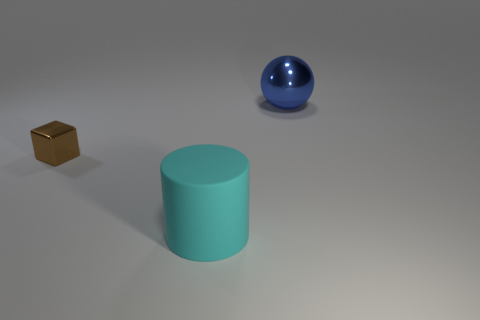Does the large blue thing have the same material as the big cylinder?
Provide a short and direct response. No. What shape is the other object that is the same size as the cyan thing?
Provide a short and direct response. Sphere. There is a thing that is left of the large thing in front of the shiny thing right of the big cyan rubber object; what is it made of?
Offer a very short reply. Metal. What number of other objects are there of the same material as the cyan cylinder?
Make the answer very short. 0. Is the object that is in front of the small brown metallic cube made of the same material as the thing that is behind the brown metallic thing?
Keep it short and to the point. No. There is a brown object that is the same material as the large blue sphere; what shape is it?
Your response must be concise. Cube. How many blue matte spheres are there?
Your response must be concise. 0. What is the shape of the object that is both right of the small brown shiny object and behind the rubber cylinder?
Make the answer very short. Sphere. What shape is the object that is left of the big thing that is in front of the metal thing that is on the right side of the large cylinder?
Your answer should be compact. Cube. What is the thing that is to the left of the blue shiny object and right of the tiny brown shiny cube made of?
Your answer should be very brief. Rubber. 